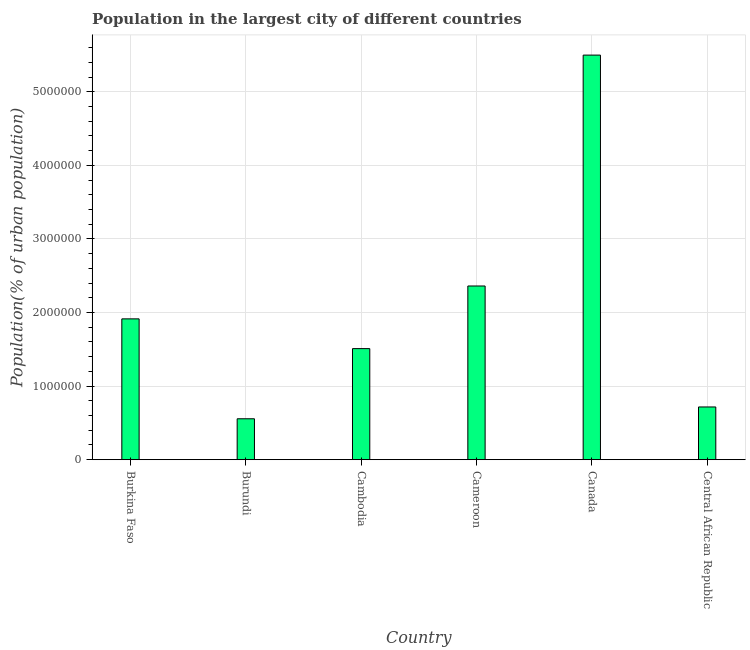Does the graph contain grids?
Give a very brief answer. Yes. What is the title of the graph?
Offer a very short reply. Population in the largest city of different countries. What is the label or title of the X-axis?
Offer a very short reply. Country. What is the label or title of the Y-axis?
Offer a terse response. Population(% of urban population). What is the population in largest city in Canada?
Your answer should be very brief. 5.50e+06. Across all countries, what is the maximum population in largest city?
Your response must be concise. 5.50e+06. Across all countries, what is the minimum population in largest city?
Your answer should be compact. 5.56e+05. In which country was the population in largest city maximum?
Ensure brevity in your answer.  Canada. In which country was the population in largest city minimum?
Your answer should be very brief. Burundi. What is the sum of the population in largest city?
Make the answer very short. 1.26e+07. What is the difference between the population in largest city in Burkina Faso and Cameroon?
Ensure brevity in your answer.  -4.47e+05. What is the average population in largest city per country?
Provide a succinct answer. 2.09e+06. What is the median population in largest city?
Your answer should be compact. 1.71e+06. What is the ratio of the population in largest city in Burkina Faso to that in Burundi?
Provide a succinct answer. 3.44. What is the difference between the highest and the second highest population in largest city?
Offer a terse response. 3.14e+06. Is the sum of the population in largest city in Cambodia and Cameroon greater than the maximum population in largest city across all countries?
Offer a terse response. No. What is the difference between the highest and the lowest population in largest city?
Your answer should be compact. 4.94e+06. In how many countries, is the population in largest city greater than the average population in largest city taken over all countries?
Offer a very short reply. 2. How many countries are there in the graph?
Give a very brief answer. 6. What is the difference between two consecutive major ticks on the Y-axis?
Make the answer very short. 1.00e+06. Are the values on the major ticks of Y-axis written in scientific E-notation?
Your answer should be very brief. No. What is the Population(% of urban population) of Burkina Faso?
Offer a terse response. 1.91e+06. What is the Population(% of urban population) in Burundi?
Your answer should be very brief. 5.56e+05. What is the Population(% of urban population) in Cambodia?
Your answer should be very brief. 1.51e+06. What is the Population(% of urban population) in Cameroon?
Ensure brevity in your answer.  2.36e+06. What is the Population(% of urban population) of Canada?
Keep it short and to the point. 5.50e+06. What is the Population(% of urban population) in Central African Republic?
Provide a succinct answer. 7.17e+05. What is the difference between the Population(% of urban population) in Burkina Faso and Burundi?
Your answer should be very brief. 1.36e+06. What is the difference between the Population(% of urban population) in Burkina Faso and Cambodia?
Your answer should be very brief. 4.04e+05. What is the difference between the Population(% of urban population) in Burkina Faso and Cameroon?
Your answer should be compact. -4.47e+05. What is the difference between the Population(% of urban population) in Burkina Faso and Canada?
Offer a terse response. -3.59e+06. What is the difference between the Population(% of urban population) in Burkina Faso and Central African Republic?
Your response must be concise. 1.20e+06. What is the difference between the Population(% of urban population) in Burundi and Cambodia?
Ensure brevity in your answer.  -9.53e+05. What is the difference between the Population(% of urban population) in Burundi and Cameroon?
Keep it short and to the point. -1.80e+06. What is the difference between the Population(% of urban population) in Burundi and Canada?
Your answer should be very brief. -4.94e+06. What is the difference between the Population(% of urban population) in Burundi and Central African Republic?
Your response must be concise. -1.60e+05. What is the difference between the Population(% of urban population) in Cambodia and Cameroon?
Your response must be concise. -8.51e+05. What is the difference between the Population(% of urban population) in Cambodia and Canada?
Your response must be concise. -3.99e+06. What is the difference between the Population(% of urban population) in Cambodia and Central African Republic?
Provide a short and direct response. 7.93e+05. What is the difference between the Population(% of urban population) in Cameroon and Canada?
Your response must be concise. -3.14e+06. What is the difference between the Population(% of urban population) in Cameroon and Central African Republic?
Your response must be concise. 1.64e+06. What is the difference between the Population(% of urban population) in Canada and Central African Republic?
Provide a short and direct response. 4.78e+06. What is the ratio of the Population(% of urban population) in Burkina Faso to that in Burundi?
Your answer should be compact. 3.44. What is the ratio of the Population(% of urban population) in Burkina Faso to that in Cambodia?
Make the answer very short. 1.27. What is the ratio of the Population(% of urban population) in Burkina Faso to that in Cameroon?
Offer a terse response. 0.81. What is the ratio of the Population(% of urban population) in Burkina Faso to that in Canada?
Your answer should be very brief. 0.35. What is the ratio of the Population(% of urban population) in Burkina Faso to that in Central African Republic?
Give a very brief answer. 2.67. What is the ratio of the Population(% of urban population) in Burundi to that in Cambodia?
Ensure brevity in your answer.  0.37. What is the ratio of the Population(% of urban population) in Burundi to that in Cameroon?
Keep it short and to the point. 0.24. What is the ratio of the Population(% of urban population) in Burundi to that in Canada?
Keep it short and to the point. 0.1. What is the ratio of the Population(% of urban population) in Burundi to that in Central African Republic?
Your answer should be compact. 0.78. What is the ratio of the Population(% of urban population) in Cambodia to that in Cameroon?
Offer a very short reply. 0.64. What is the ratio of the Population(% of urban population) in Cambodia to that in Canada?
Keep it short and to the point. 0.28. What is the ratio of the Population(% of urban population) in Cambodia to that in Central African Republic?
Keep it short and to the point. 2.11. What is the ratio of the Population(% of urban population) in Cameroon to that in Canada?
Keep it short and to the point. 0.43. What is the ratio of the Population(% of urban population) in Cameroon to that in Central African Republic?
Make the answer very short. 3.29. What is the ratio of the Population(% of urban population) in Canada to that in Central African Republic?
Provide a succinct answer. 7.67. 